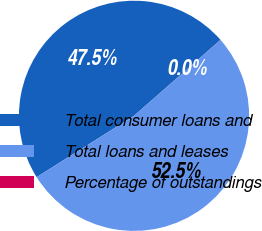Convert chart. <chart><loc_0><loc_0><loc_500><loc_500><pie_chart><fcel>Total consumer loans and<fcel>Total loans and leases<fcel>Percentage of outstandings<nl><fcel>47.48%<fcel>52.52%<fcel>0.01%<nl></chart> 